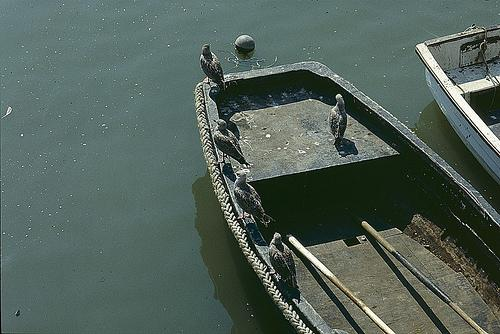What are the two long poles?

Choices:
A) oar handles
B) paint poles
C) fishing poles
D) pool cue oar handles 